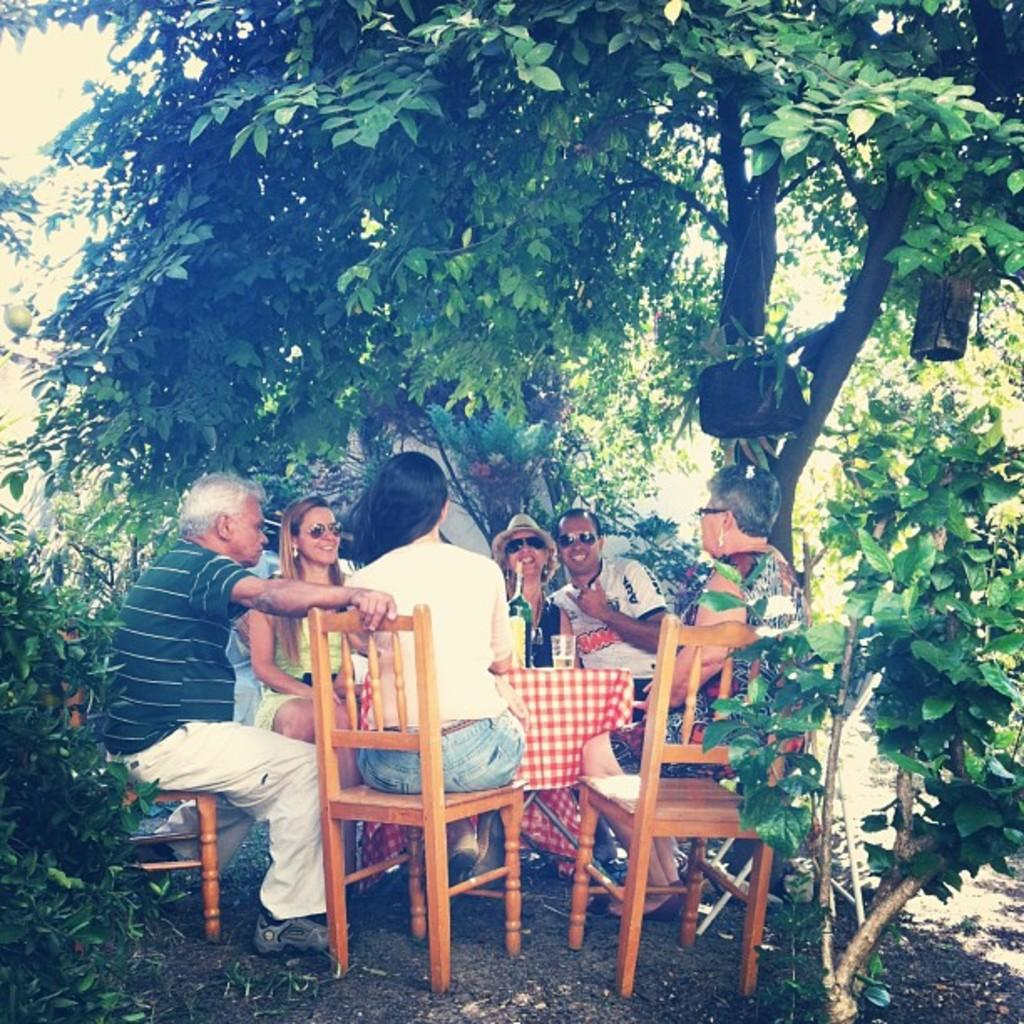How many people are in the image? There is a group of people in the image. What are the people doing in the image? The people are having a party. Where is the party taking place? The party is taking place in a garden. What can be found in the garden? There is a tree in the garden. What type of game is being played in the garden during the party? There is no game being played in the garden during the party; the image only shows people having a party in a garden with a tree. 